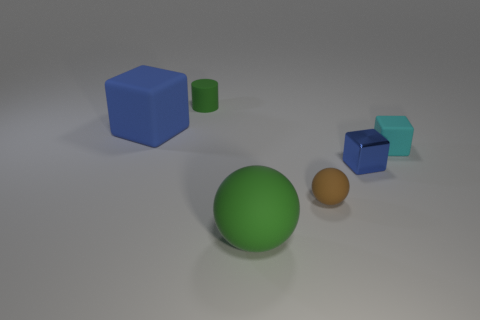Is the size of the cyan cube the same as the shiny object?
Offer a very short reply. Yes. Are there any other things that are the same shape as the small brown thing?
Give a very brief answer. Yes. What number of things are either blue things that are to the left of the tiny green cylinder or small green rubber objects?
Your answer should be compact. 2. Is the large green matte object the same shape as the small brown rubber thing?
Make the answer very short. Yes. What number of other things are there of the same size as the cyan rubber cube?
Your response must be concise. 3. The large block has what color?
Offer a very short reply. Blue. What number of small things are cylinders or spheres?
Provide a succinct answer. 2. Is the size of the green object that is behind the blue metallic object the same as the sphere that is right of the large green matte object?
Your answer should be very brief. Yes. What is the size of the blue metallic thing that is the same shape as the small cyan thing?
Provide a short and direct response. Small. Are there more matte cubes to the right of the tiny brown rubber ball than blue rubber objects right of the big blue matte cube?
Your answer should be very brief. Yes. 